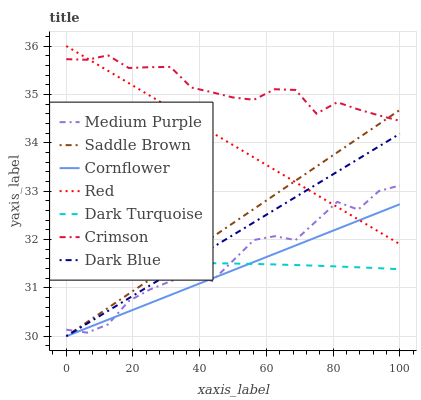Does Cornflower have the minimum area under the curve?
Answer yes or no. Yes. Does Crimson have the maximum area under the curve?
Answer yes or no. Yes. Does Dark Turquoise have the minimum area under the curve?
Answer yes or no. No. Does Dark Turquoise have the maximum area under the curve?
Answer yes or no. No. Is Cornflower the smoothest?
Answer yes or no. Yes. Is Medium Purple the roughest?
Answer yes or no. Yes. Is Dark Turquoise the smoothest?
Answer yes or no. No. Is Dark Turquoise the roughest?
Answer yes or no. No. Does Cornflower have the lowest value?
Answer yes or no. Yes. Does Dark Turquoise have the lowest value?
Answer yes or no. No. Does Red have the highest value?
Answer yes or no. Yes. Does Medium Purple have the highest value?
Answer yes or no. No. Is Dark Turquoise less than Red?
Answer yes or no. Yes. Is Crimson greater than Dark Turquoise?
Answer yes or no. Yes. Does Red intersect Medium Purple?
Answer yes or no. Yes. Is Red less than Medium Purple?
Answer yes or no. No. Is Red greater than Medium Purple?
Answer yes or no. No. Does Dark Turquoise intersect Red?
Answer yes or no. No. 